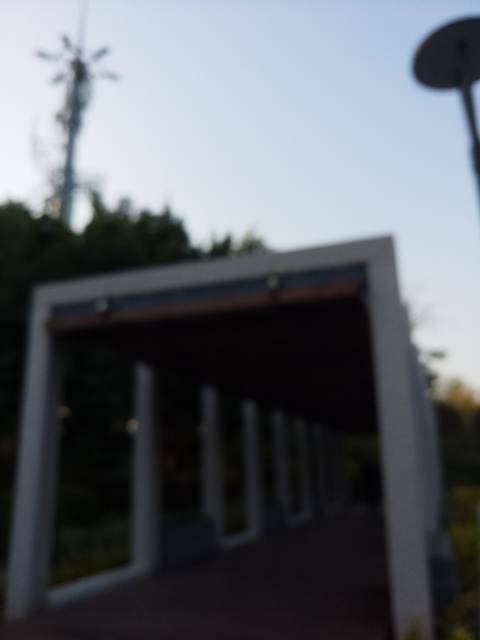What are some possible reasons why this photo is out of focus? There could be several reasons why the photo is out of focus. It might be an accidental camera shake during a low-light condition or an incorrect autofocus setting. It could also be a deliberate artistic choice to emphasize the mood over detail or to encourage viewers to imagine what the scene might look like. 